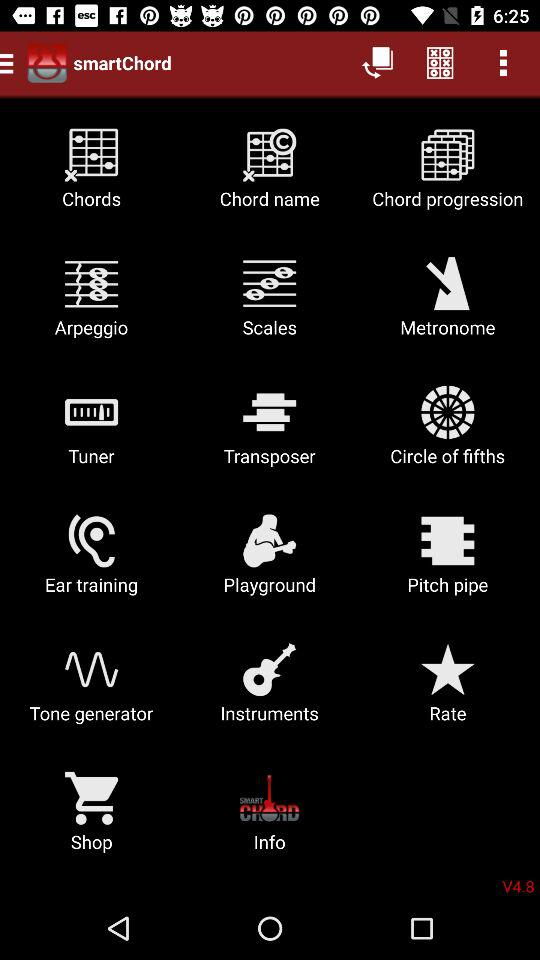What is the application name? The application name is "smartChord". 